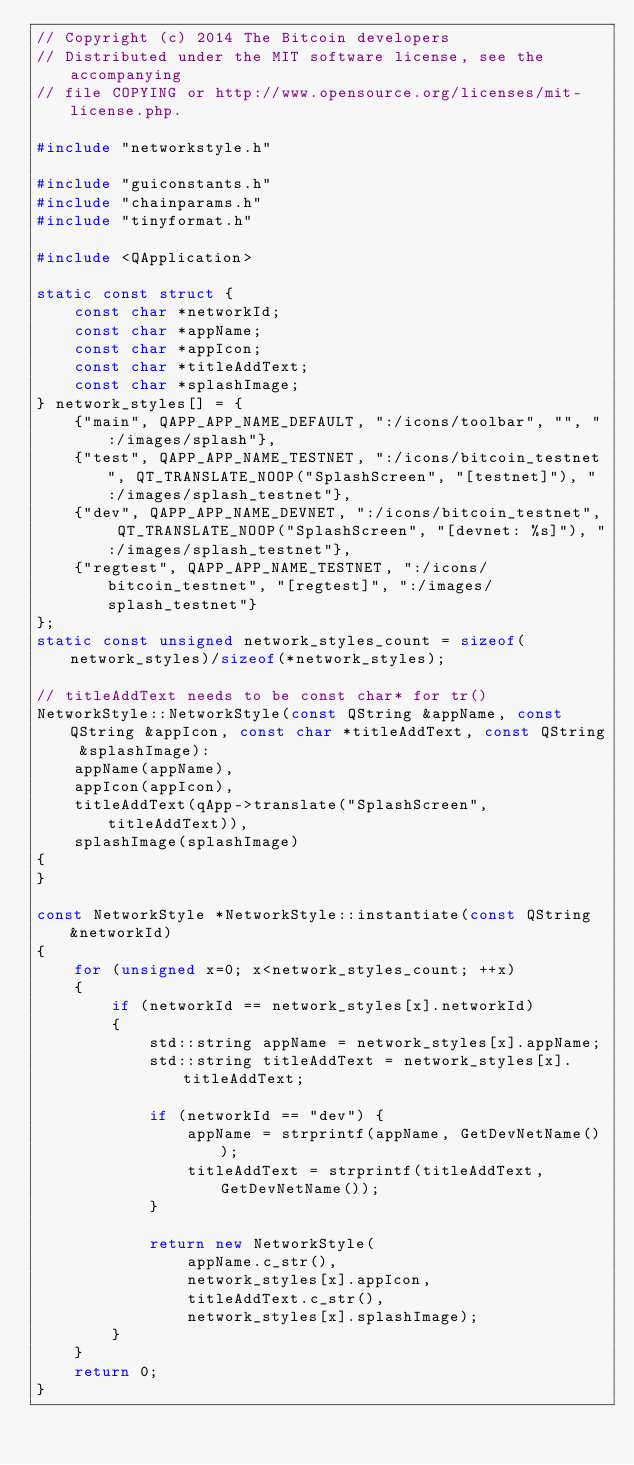<code> <loc_0><loc_0><loc_500><loc_500><_C++_>// Copyright (c) 2014 The Bitcoin developers
// Distributed under the MIT software license, see the accompanying
// file COPYING or http://www.opensource.org/licenses/mit-license.php.

#include "networkstyle.h"

#include "guiconstants.h"
#include "chainparams.h"
#include "tinyformat.h"

#include <QApplication>

static const struct {
    const char *networkId;
    const char *appName;
    const char *appIcon;
    const char *titleAddText;
    const char *splashImage;
} network_styles[] = {
    {"main", QAPP_APP_NAME_DEFAULT, ":/icons/toolbar", "", ":/images/splash"},
    {"test", QAPP_APP_NAME_TESTNET, ":/icons/bitcoin_testnet", QT_TRANSLATE_NOOP("SplashScreen", "[testnet]"), ":/images/splash_testnet"},
    {"dev", QAPP_APP_NAME_DEVNET, ":/icons/bitcoin_testnet", QT_TRANSLATE_NOOP("SplashScreen", "[devnet: %s]"), ":/images/splash_testnet"},
    {"regtest", QAPP_APP_NAME_TESTNET, ":/icons/bitcoin_testnet", "[regtest]", ":/images/splash_testnet"}
};
static const unsigned network_styles_count = sizeof(network_styles)/sizeof(*network_styles);

// titleAddText needs to be const char* for tr()
NetworkStyle::NetworkStyle(const QString &appName, const QString &appIcon, const char *titleAddText, const QString &splashImage):
    appName(appName),
    appIcon(appIcon),
    titleAddText(qApp->translate("SplashScreen", titleAddText)),
    splashImage(splashImage)
{
}

const NetworkStyle *NetworkStyle::instantiate(const QString &networkId)
{
    for (unsigned x=0; x<network_styles_count; ++x)
    {
        if (networkId == network_styles[x].networkId)
        {
            std::string appName = network_styles[x].appName;
            std::string titleAddText = network_styles[x].titleAddText;

            if (networkId == "dev") {
                appName = strprintf(appName, GetDevNetName());
                titleAddText = strprintf(titleAddText, GetDevNetName());
            }

            return new NetworkStyle(
                appName.c_str(),
                network_styles[x].appIcon,
                titleAddText.c_str(),
                network_styles[x].splashImage);
        }
    }
    return 0;
}
</code> 